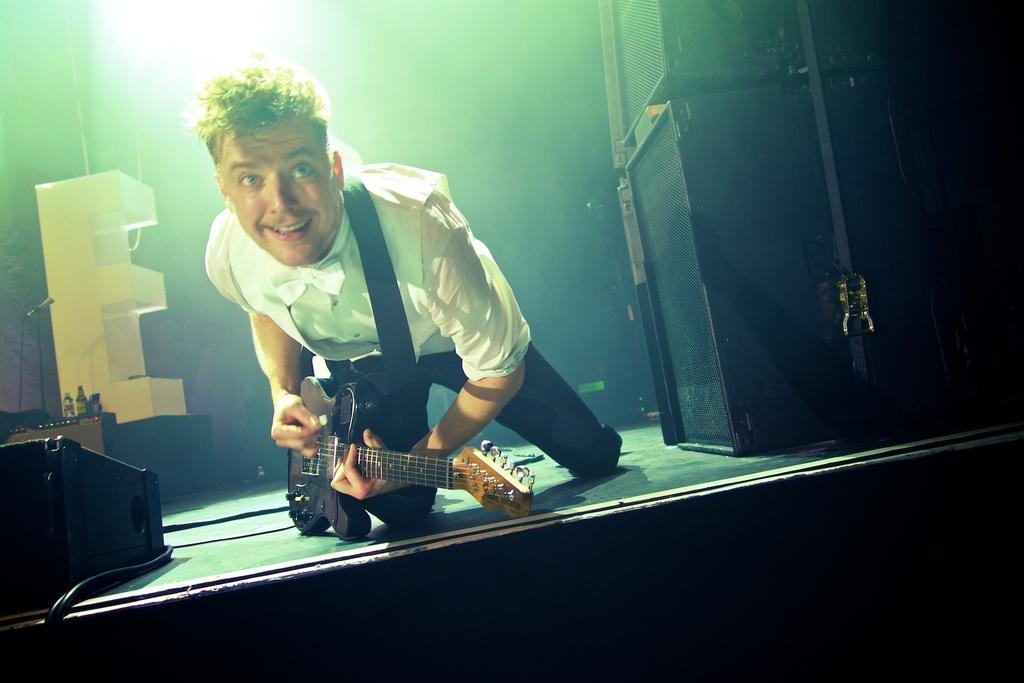What is the person in the image doing? The person is bending in the image. What is the person holding while bending? The person is holding a guitar. What can be seen on the right side of the image? There are speakers on the right side of the image. What is located on the left side of the image? There is a statue named "E" on the left side of the image. What type of alley can be seen in the background of the image? There is no alley present in the image; it is not mentioned in the provided facts. 